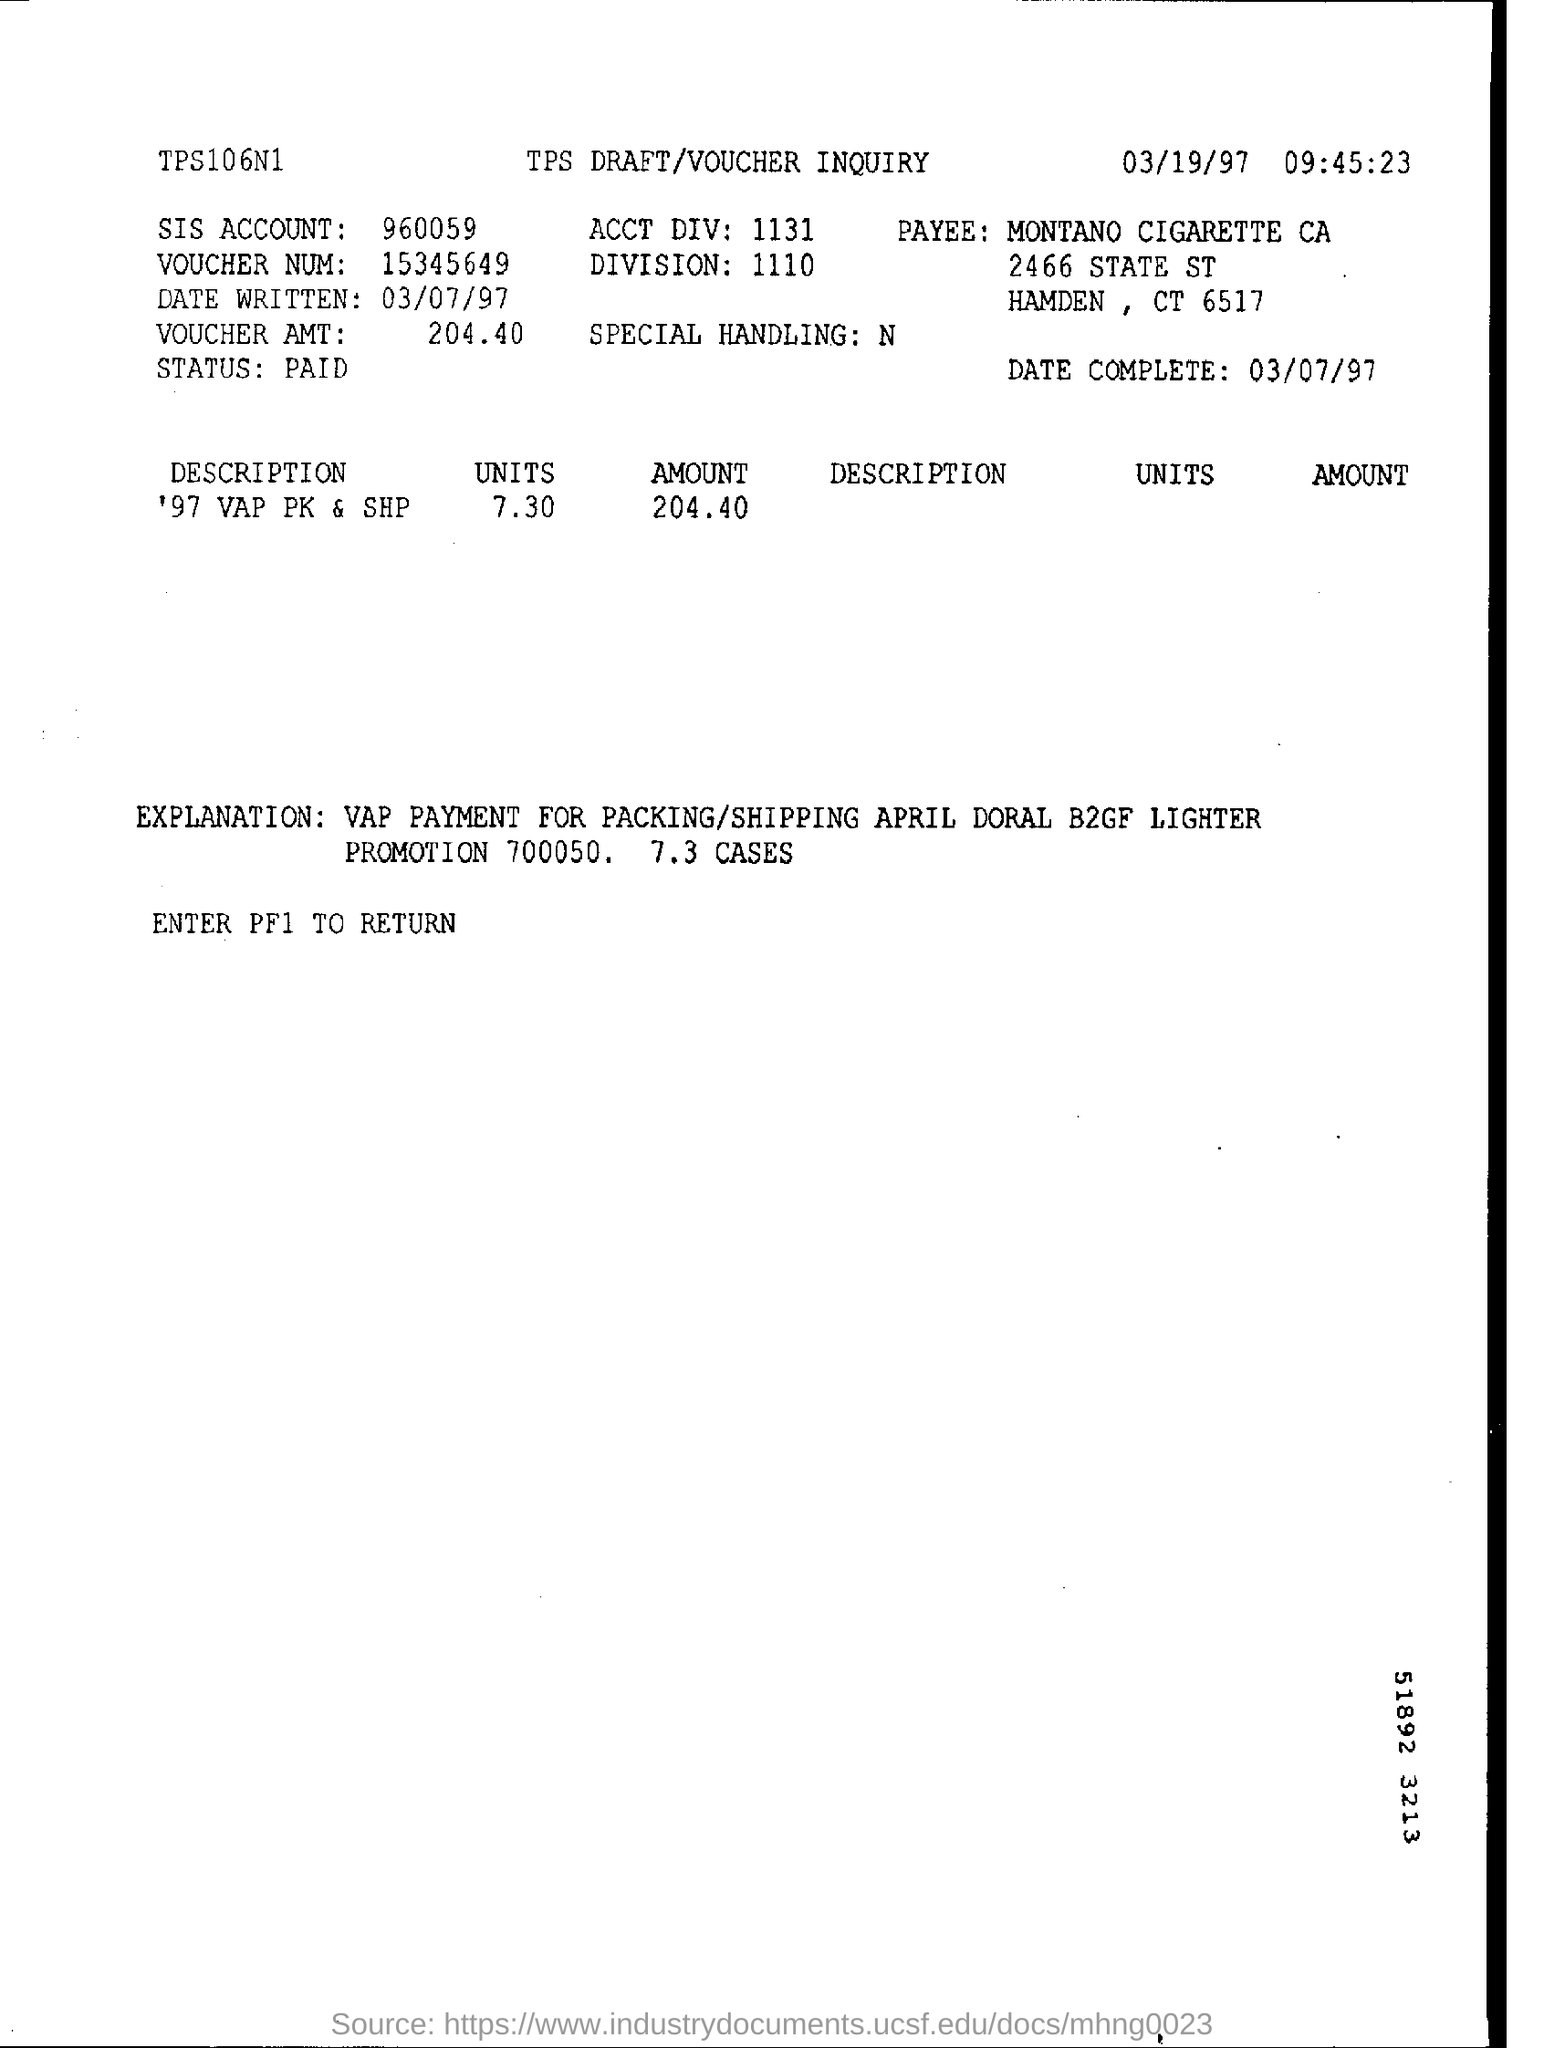Specify some key components in this picture. What is the division number? It is 1110. The voucher amount is 204.40. The date written is 03/07/97. The payment has been made and is considered paid. The time mentioned is 09:45:23. 